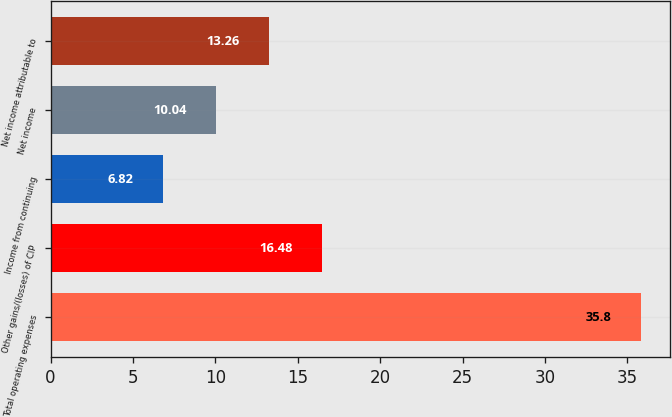<chart> <loc_0><loc_0><loc_500><loc_500><bar_chart><fcel>Total operating expenses<fcel>Other gains/(losses) of CIP<fcel>Income from continuing<fcel>Net income<fcel>Net income attributable to<nl><fcel>35.8<fcel>16.48<fcel>6.82<fcel>10.04<fcel>13.26<nl></chart> 